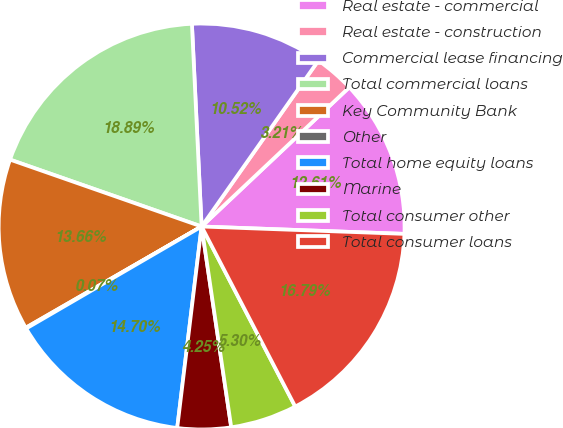<chart> <loc_0><loc_0><loc_500><loc_500><pie_chart><fcel>Real estate - commercial<fcel>Real estate - construction<fcel>Commercial lease financing<fcel>Total commercial loans<fcel>Key Community Bank<fcel>Other<fcel>Total home equity loans<fcel>Marine<fcel>Total consumer other<fcel>Total consumer loans<nl><fcel>12.61%<fcel>3.21%<fcel>10.52%<fcel>18.89%<fcel>13.66%<fcel>0.07%<fcel>14.7%<fcel>4.25%<fcel>5.3%<fcel>16.79%<nl></chart> 